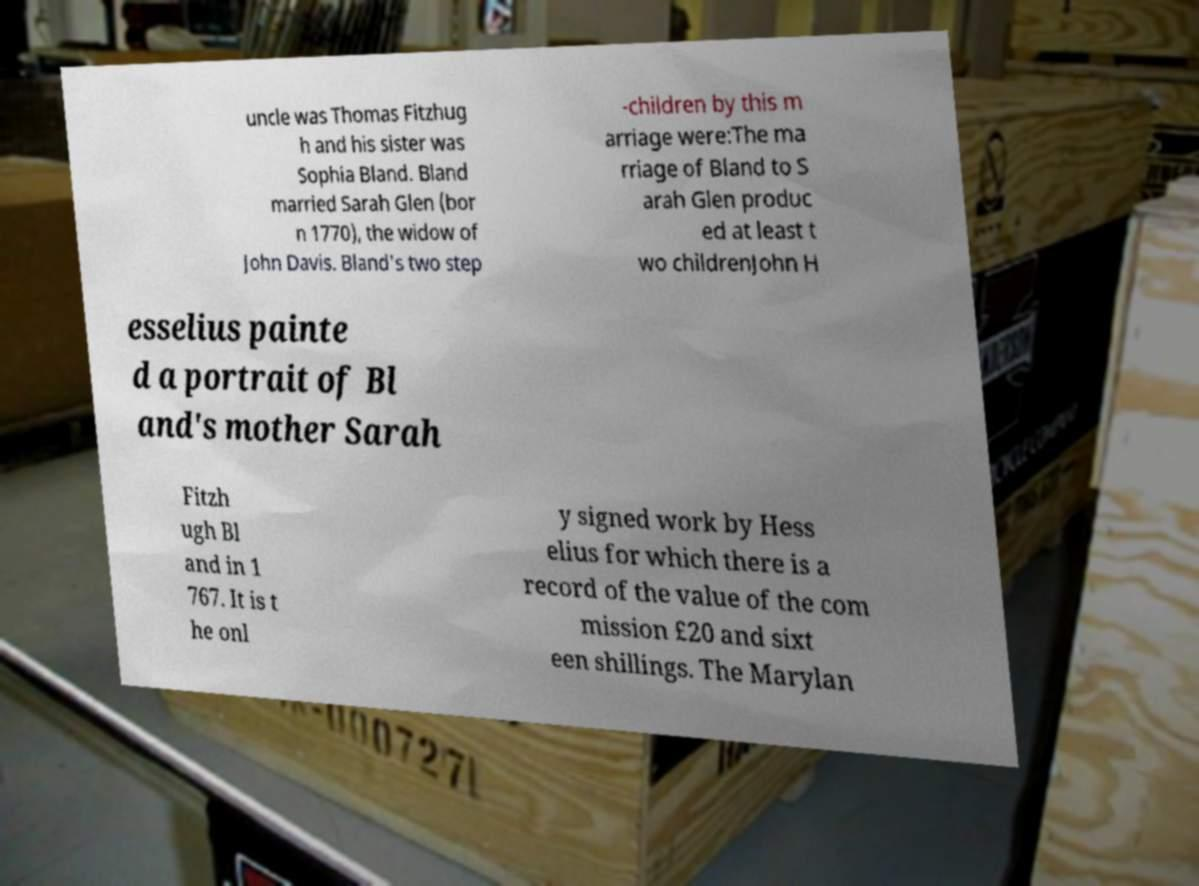Could you extract and type out the text from this image? uncle was Thomas Fitzhug h and his sister was Sophia Bland. Bland married Sarah Glen (bor n 1770), the widow of John Davis. Bland's two step -children by this m arriage were:The ma rriage of Bland to S arah Glen produc ed at least t wo childrenJohn H esselius painte d a portrait of Bl and's mother Sarah Fitzh ugh Bl and in 1 767. It is t he onl y signed work by Hess elius for which there is a record of the value of the com mission £20 and sixt een shillings. The Marylan 